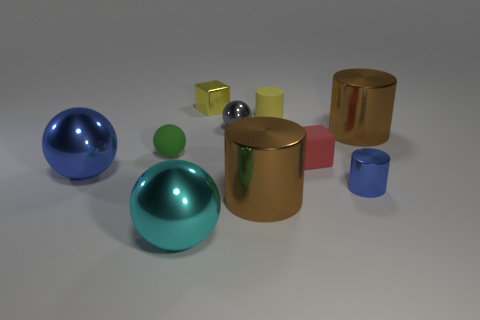Is there a blue rubber object that has the same shape as the red thing?
Your response must be concise. No. Are there the same number of tiny red matte blocks that are behind the tiny green sphere and cyan metal objects that are behind the small blue object?
Ensure brevity in your answer.  Yes. Do the yellow object that is on the left side of the small matte cylinder and the small blue metallic thing have the same shape?
Offer a very short reply. No. Does the yellow shiny thing have the same shape as the tiny red object?
Make the answer very short. Yes. What number of matte objects are either large purple things or red blocks?
Offer a terse response. 1. What is the material of the big sphere that is the same color as the small shiny cylinder?
Your answer should be very brief. Metal. Does the yellow rubber cylinder have the same size as the blue ball?
Provide a succinct answer. No. What number of things are big cyan metal balls or tiny things behind the tiny green thing?
Provide a short and direct response. 4. There is a gray sphere that is the same size as the matte block; what is its material?
Your answer should be compact. Metal. What is the large object that is both to the right of the tiny yellow metallic object and in front of the small green object made of?
Offer a terse response. Metal. 